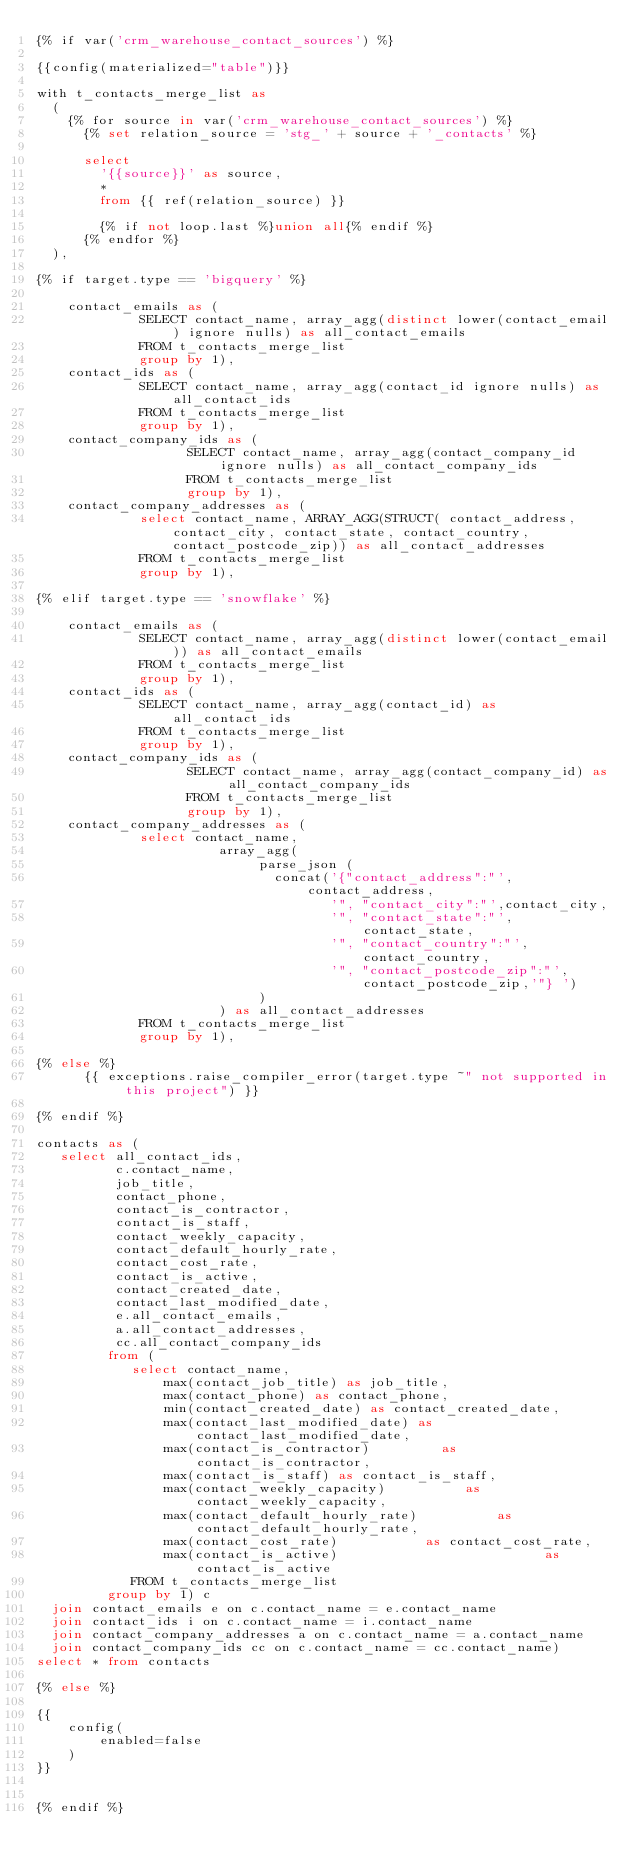Convert code to text. <code><loc_0><loc_0><loc_500><loc_500><_SQL_>{% if var('crm_warehouse_contact_sources') %}

{{config(materialized="table")}}

with t_contacts_merge_list as
  (
    {% for source in var('crm_warehouse_contact_sources') %}
      {% set relation_source = 'stg_' + source + '_contacts' %}

      select
        '{{source}}' as source,
        *
        from {{ ref(relation_source) }}

        {% if not loop.last %}union all{% endif %}
      {% endfor %}
  ),

{% if target.type == 'bigquery' %}

    contact_emails as (
             SELECT contact_name, array_agg(distinct lower(contact_email) ignore nulls) as all_contact_emails
             FROM t_contacts_merge_list
             group by 1),
    contact_ids as (
             SELECT contact_name, array_agg(contact_id ignore nulls) as all_contact_ids
             FROM t_contacts_merge_list
             group by 1),
    contact_company_ids as (
                   SELECT contact_name, array_agg(contact_company_id ignore nulls) as all_contact_company_ids
                   FROM t_contacts_merge_list
                   group by 1),
    contact_company_addresses as (
             select contact_name, ARRAY_AGG(STRUCT( contact_address, contact_city, contact_state, contact_country, contact_postcode_zip)) as all_contact_addresses
             FROM t_contacts_merge_list
             group by 1),

{% elif target.type == 'snowflake' %}

    contact_emails as (
             SELECT contact_name, array_agg(distinct lower(contact_email)) as all_contact_emails
             FROM t_contacts_merge_list
             group by 1),
    contact_ids as (
             SELECT contact_name, array_agg(contact_id) as all_contact_ids
             FROM t_contacts_merge_list
             group by 1),
    contact_company_ids as (
                   SELECT contact_name, array_agg(contact_company_id) as all_contact_company_ids
                   FROM t_contacts_merge_list
                   group by 1),
    contact_company_addresses as (
             select contact_name,
                       array_agg(
                            parse_json (
                              concat('{"contact_address":"',contact_address,
                                     '", "contact_city":"',contact_city,
                                     '", "contact_state":"',contact_state,
                                     '", "contact_country":"',contact_country,
                                     '", "contact_postcode_zip":"',contact_postcode_zip,'"} ')
                            )
                       ) as all_contact_addresses
             FROM t_contacts_merge_list
             group by 1),

{% else %}
      {{ exceptions.raise_compiler_error(target.type ~" not supported in this project") }}

{% endif %}

contacts as (
   select all_contact_ids,
          c.contact_name,
          job_title,
          contact_phone,
          contact_is_contractor,
          contact_is_staff,
          contact_weekly_capacity,
          contact_default_hourly_rate,
          contact_cost_rate,
          contact_is_active,
          contact_created_date,
          contact_last_modified_date,
          e.all_contact_emails,
          a.all_contact_addresses,
          cc.all_contact_company_ids
         from (
            select contact_name,
                max(contact_job_title) as job_title,
                max(contact_phone) as contact_phone,
                min(contact_created_date) as contact_created_date,
                max(contact_last_modified_date) as contact_last_modified_date,
                max(contact_is_contractor)         as contact_is_contractor,
                max(contact_is_staff) as contact_is_staff,
                max(contact_weekly_capacity)          as contact_weekly_capacity,
                max(contact_default_hourly_rate)          as contact_default_hourly_rate,
                max(contact_cost_rate)           as contact_cost_rate,
                max(contact_is_active)                          as contact_is_active
            FROM t_contacts_merge_list
         group by 1) c
  join contact_emails e on c.contact_name = e.contact_name
  join contact_ids i on c.contact_name = i.contact_name
  join contact_company_addresses a on c.contact_name = a.contact_name
  join contact_company_ids cc on c.contact_name = cc.contact_name)
select * from contacts

{% else %}

{{
    config(
        enabled=false
    )
}}


{% endif %}
</code> 